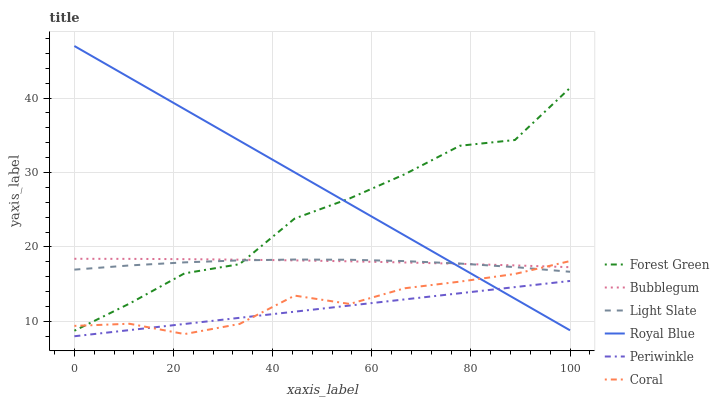Does Periwinkle have the minimum area under the curve?
Answer yes or no. Yes. Does Royal Blue have the maximum area under the curve?
Answer yes or no. Yes. Does Coral have the minimum area under the curve?
Answer yes or no. No. Does Coral have the maximum area under the curve?
Answer yes or no. No. Is Periwinkle the smoothest?
Answer yes or no. Yes. Is Forest Green the roughest?
Answer yes or no. Yes. Is Coral the smoothest?
Answer yes or no. No. Is Coral the roughest?
Answer yes or no. No. Does Coral have the lowest value?
Answer yes or no. No. Does Royal Blue have the highest value?
Answer yes or no. Yes. Does Coral have the highest value?
Answer yes or no. No. Is Periwinkle less than Light Slate?
Answer yes or no. Yes. Is Forest Green greater than Periwinkle?
Answer yes or no. Yes. Does Forest Green intersect Light Slate?
Answer yes or no. Yes. Is Forest Green less than Light Slate?
Answer yes or no. No. Is Forest Green greater than Light Slate?
Answer yes or no. No. Does Periwinkle intersect Light Slate?
Answer yes or no. No. 